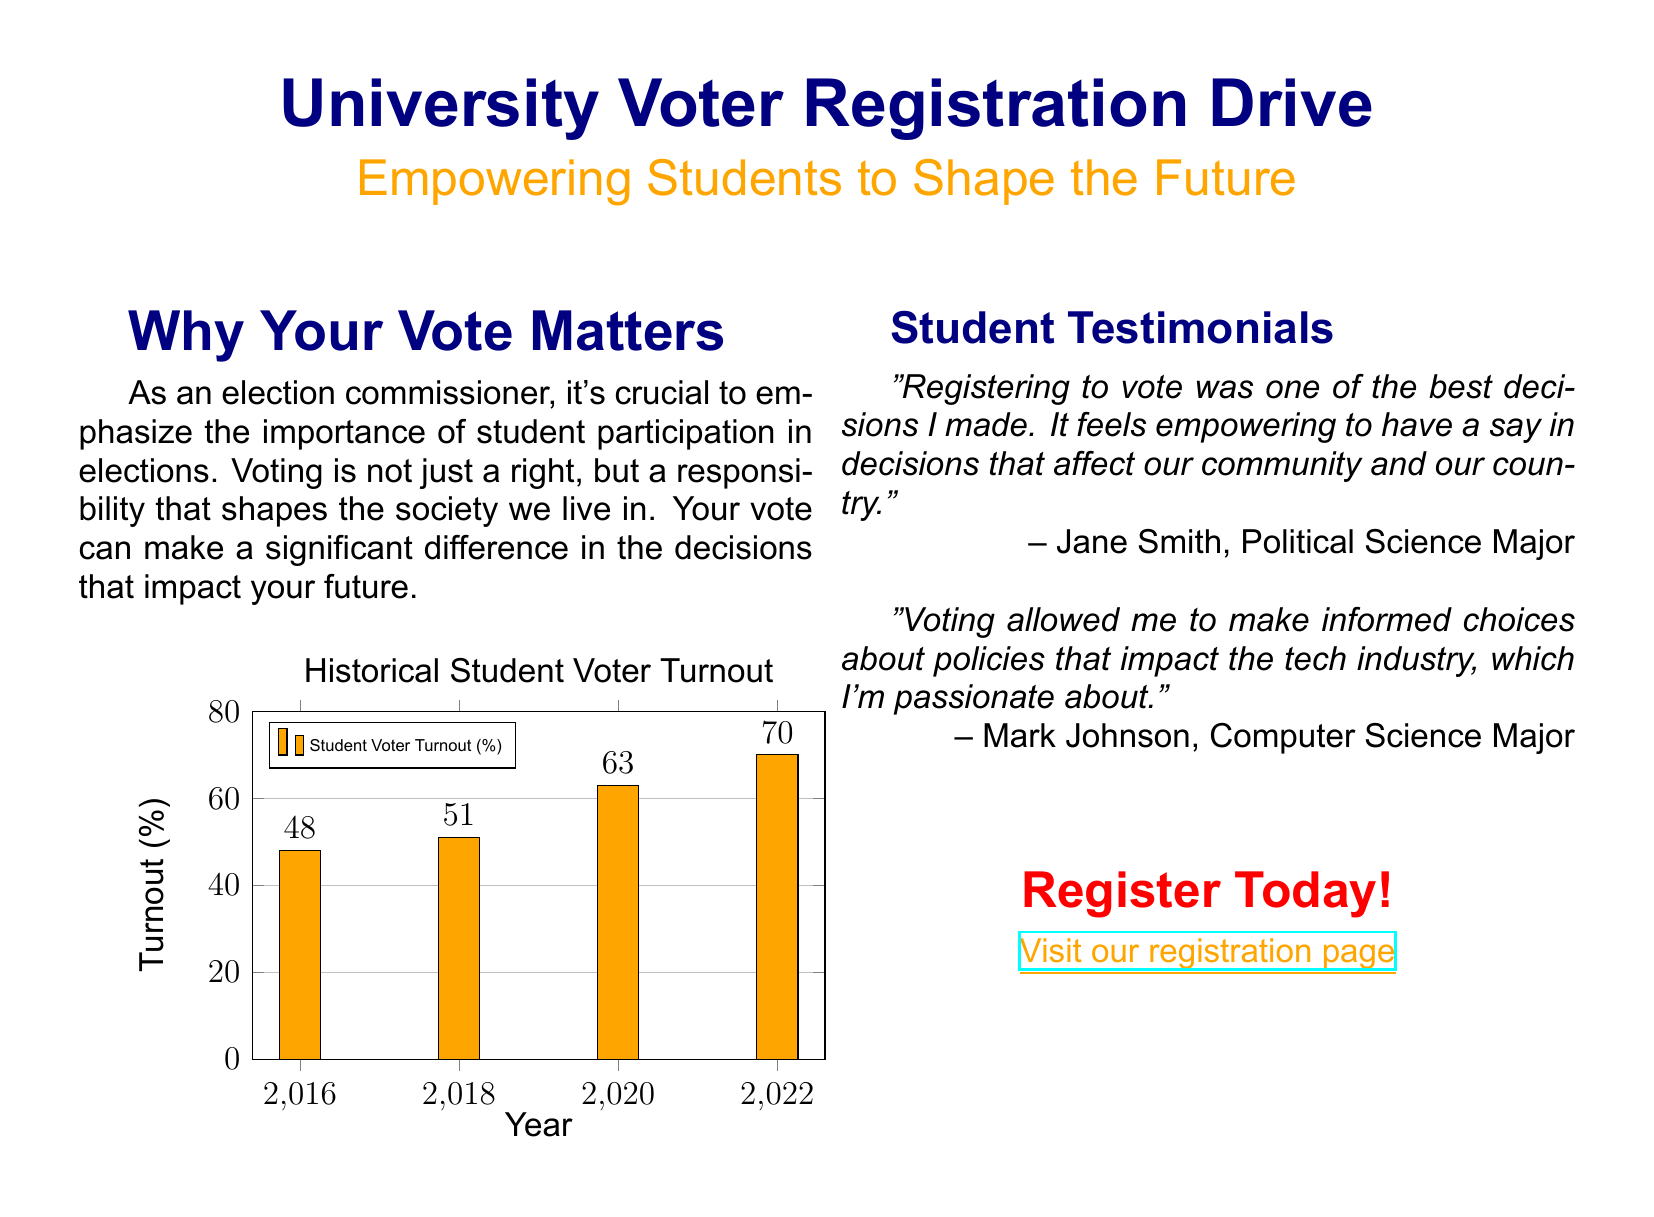What is the title of the advertisement? The title is prominently displayed at the top of the advertisement to capture attention.
Answer: University Voter Registration Drive What is the main message highlighted in orange? The orange text emphasizes the call to action and purpose of the advertisement.
Answer: Empowering Students to Shape the Future What was the student voter turnout in 2022? The chart provides historical data on student voter turnout for different years, including 2022.
Answer: 70 Who is quoted as saying registering to vote was empowering? The testimonial section includes quotes from students about their voting experiences.
Answer: Jane Smith In which year did the student voter turnout first exceed 50%? Reasoning involves looking at the turnout data from the chart provided.
Answer: 2020 What is the main purpose of the document? The document is designed to inform and encourage a specific action related to voting.
Answer: Voter registration What color is used for the title text? The color choice is mentioned in the document for thematic purposes.
Answer: Navy blue What is the website link for voter registration? The hyperlink directs students to the registration page as an actionable step.
Answer: www.universityvote.org/register 